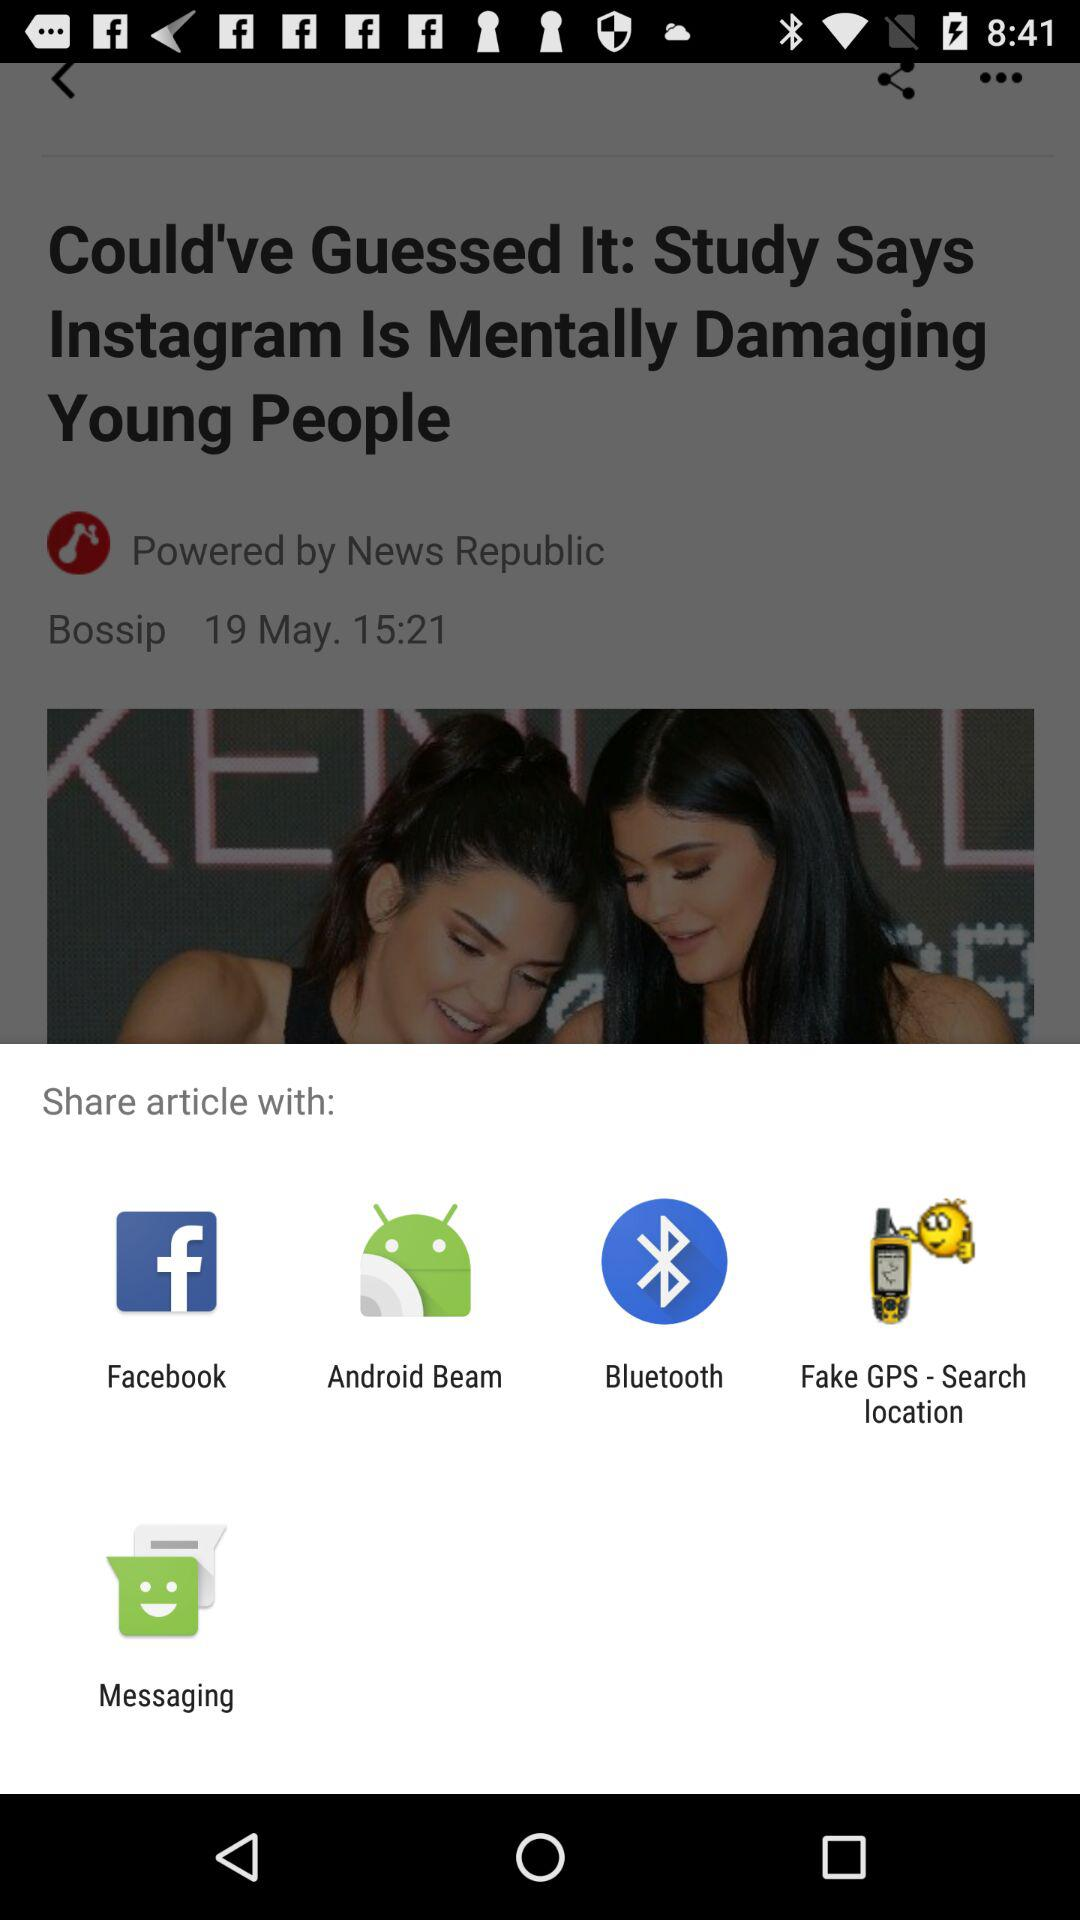What is the name of the article's author? The name of the article's author is "News Republic". 